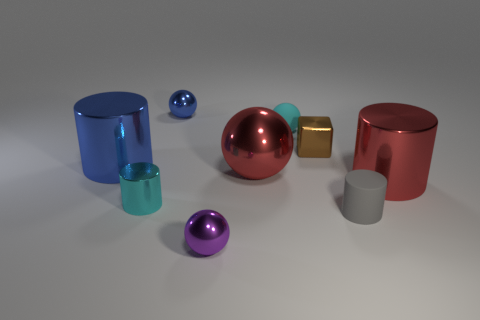Is the number of cyan metal blocks greater than the number of large blue objects?
Make the answer very short. No. Are there any cylinders that have the same size as the red ball?
Your response must be concise. Yes. How many objects are tiny shiny objects that are behind the rubber cylinder or metallic cylinders that are on the right side of the cyan shiny object?
Offer a terse response. 4. There is a large metal cylinder on the left side of the cyan thing that is to the right of the purple thing; what is its color?
Offer a terse response. Blue. What is the color of the small cylinder that is made of the same material as the small brown block?
Ensure brevity in your answer.  Cyan. What number of small matte objects have the same color as the matte ball?
Your answer should be very brief. 0. How many objects are either small brown things or tiny green balls?
Provide a short and direct response. 1. What is the shape of the cyan object that is the same size as the cyan matte ball?
Give a very brief answer. Cylinder. What number of metal things are both behind the tiny shiny cylinder and in front of the cyan matte sphere?
Your answer should be compact. 4. What is the material of the tiny sphere in front of the tiny cyan metallic object?
Provide a short and direct response. Metal. 